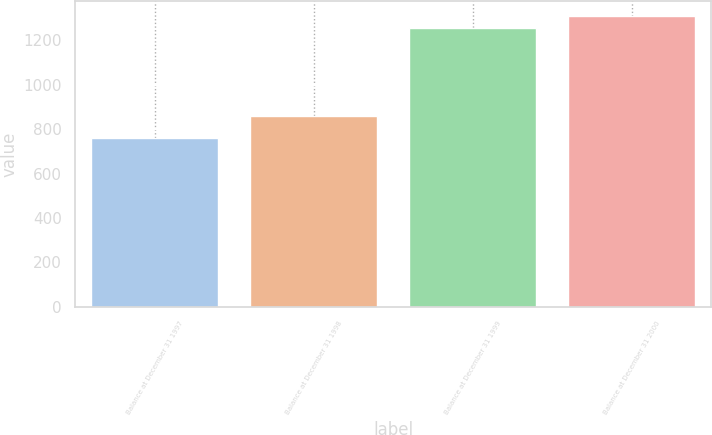Convert chart to OTSL. <chart><loc_0><loc_0><loc_500><loc_500><bar_chart><fcel>Balance at December 31 1997<fcel>Balance at December 31 1998<fcel>Balance at December 31 1999<fcel>Balance at December 31 2000<nl><fcel>761<fcel>861<fcel>1258<fcel>1309.8<nl></chart> 